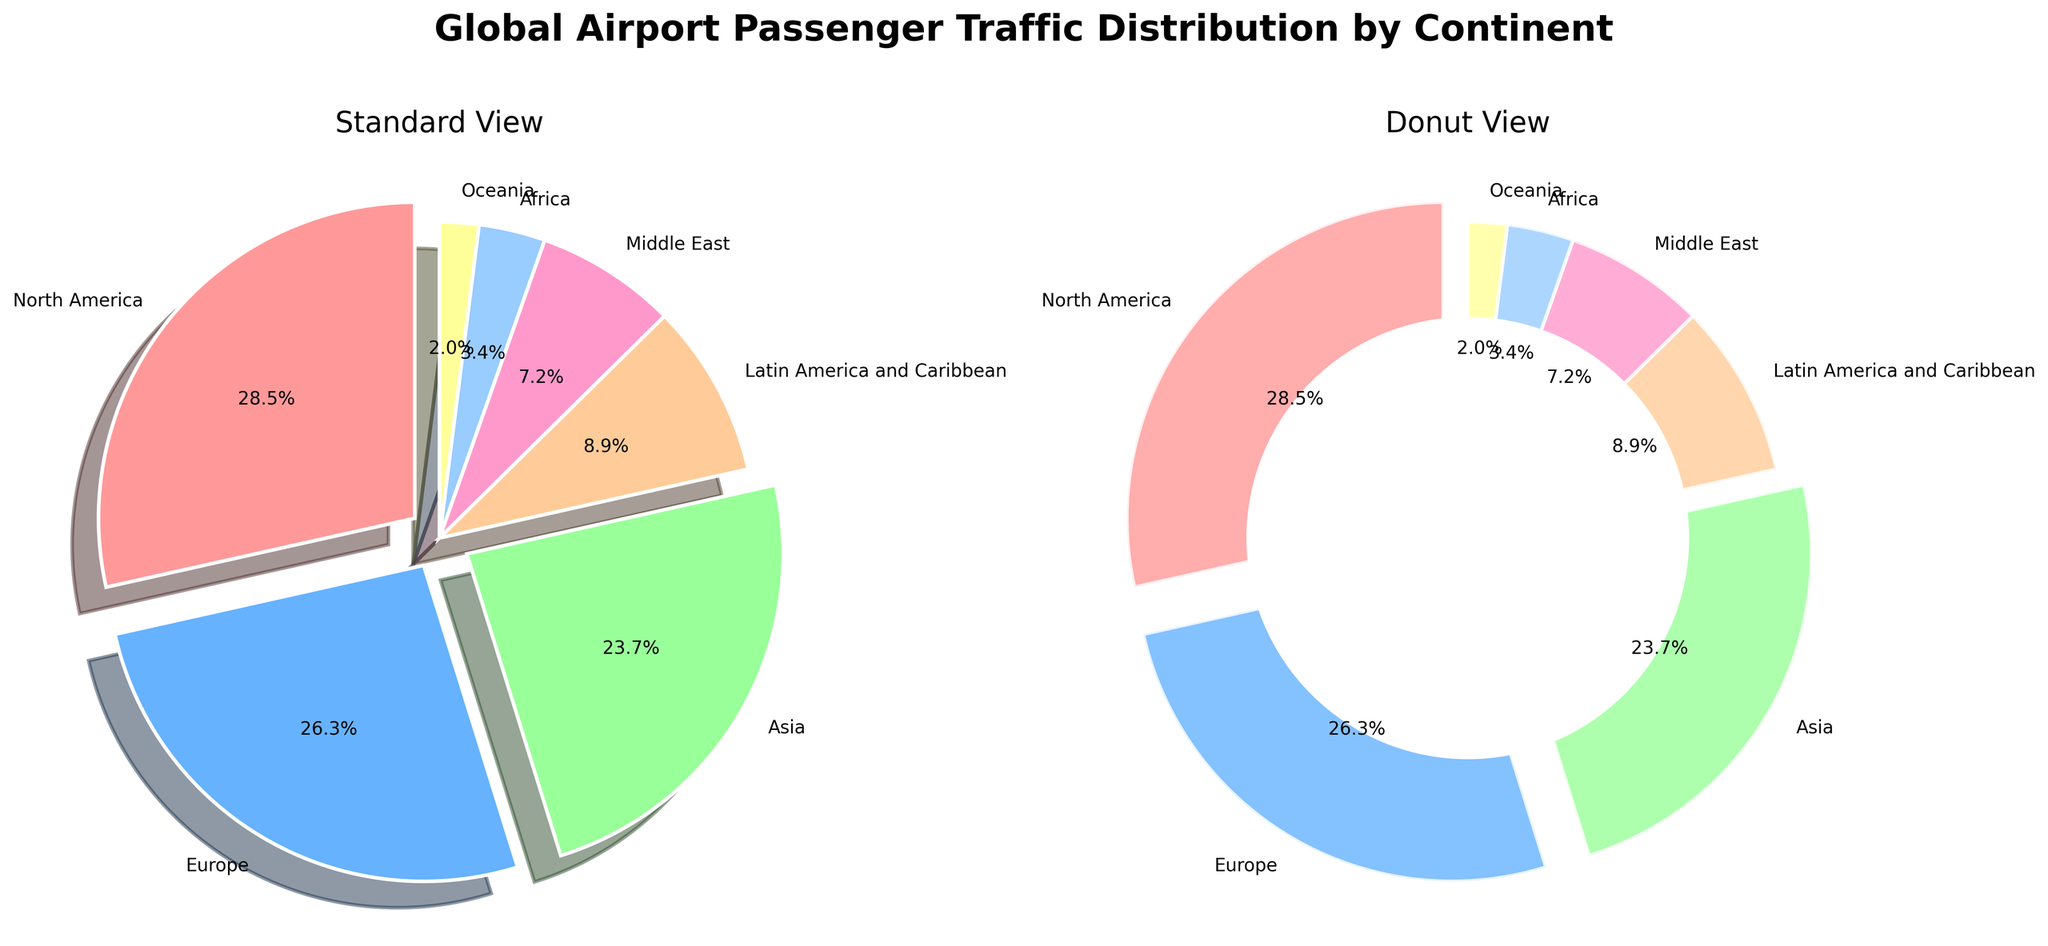What's the percentage of passenger traffic for Europe? Look at the pie chart and identify the percentage label for Europe.
Answer: 26.3% What's the combined percentage of passenger traffic for North America and Asia? Sum the percentages of passenger traffic for North America and Asia: 28.5% + 23.7% = 52.2%.
Answer: 52.2% Which continent has the lowest passenger traffic percentage? Identify the smallest percentage in the pie chart, which corresponds to Oceania at 2.0%.
Answer: Oceania Compare the passenger traffic percentages between Latin America and the Caribbean and the Middle East. Which one is higher? Look at the pie chart and compare the percentages: Latin America and the Caribbean has 8.9%, while the Middle East has 7.2%. Latin America and the Caribbean has a higher percentage.
Answer: Latin America and the Caribbean Which visual attributes are used to highlight the larger slices in the pie chart? The larger slices are highlighted using an "explode" effect, where they are slightly pulled out from the center, and the use of different colors emphasizes them.
Answer: Explode effect and different colors If you combine the passenger traffic percentages for Africa and Oceania, how does it compare to the percentage of the Middle East? Which is greater? Sum the percentages for Africa and Oceania: 3.4% + 2.0% = 5.4%. Compare this with the Middle East's 7.2%. The Middle East has a greater percentage.
Answer: Middle East What's the visual difference between the standard pie chart and the donut pie chart? The standard pie chart is a complete circle, while the donut pie chart has a blank circular area in the center, making it look like a donut.
Answer: Donut chart has a blank center Which slice is represented in red and what's the percentage for that continent? Identify the red-colored slice in the pie chart. It represents North America, with a percentage of 28.5%.
Answer: North America, 28.5% How much greater is the passenger traffic percentage for Europe compared to Africa? Subtract the percentage of Africa from the percentage of Europe: 26.3% - 3.4% = 22.9%.
Answer: 22.9% What is the average passenger traffic percentage for Africa, Oceania, and the Middle East? Sum the percentages for Africa, Oceania, and the Middle East: 3.4% + 2.0% + 7.2% = 12.6%. Then divide by the number of continents: 12.6 / 3 = 4.2%.
Answer: 4.2% 